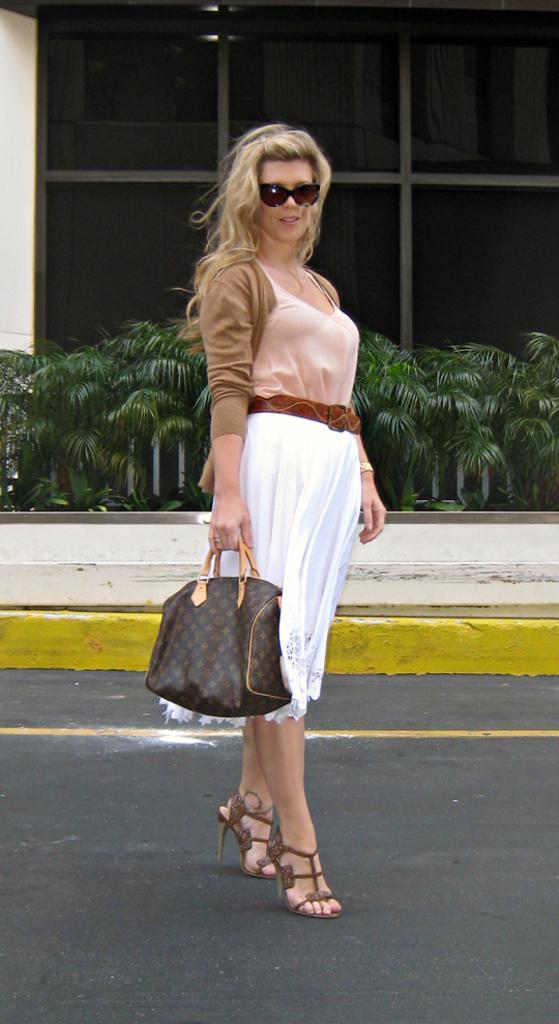In one or two sentences, can you explain what this image depicts? This picture shows a woman standing on the road, holding a bag in her hand and wearing a spectacles. In the background there are some plants and a windows here. 